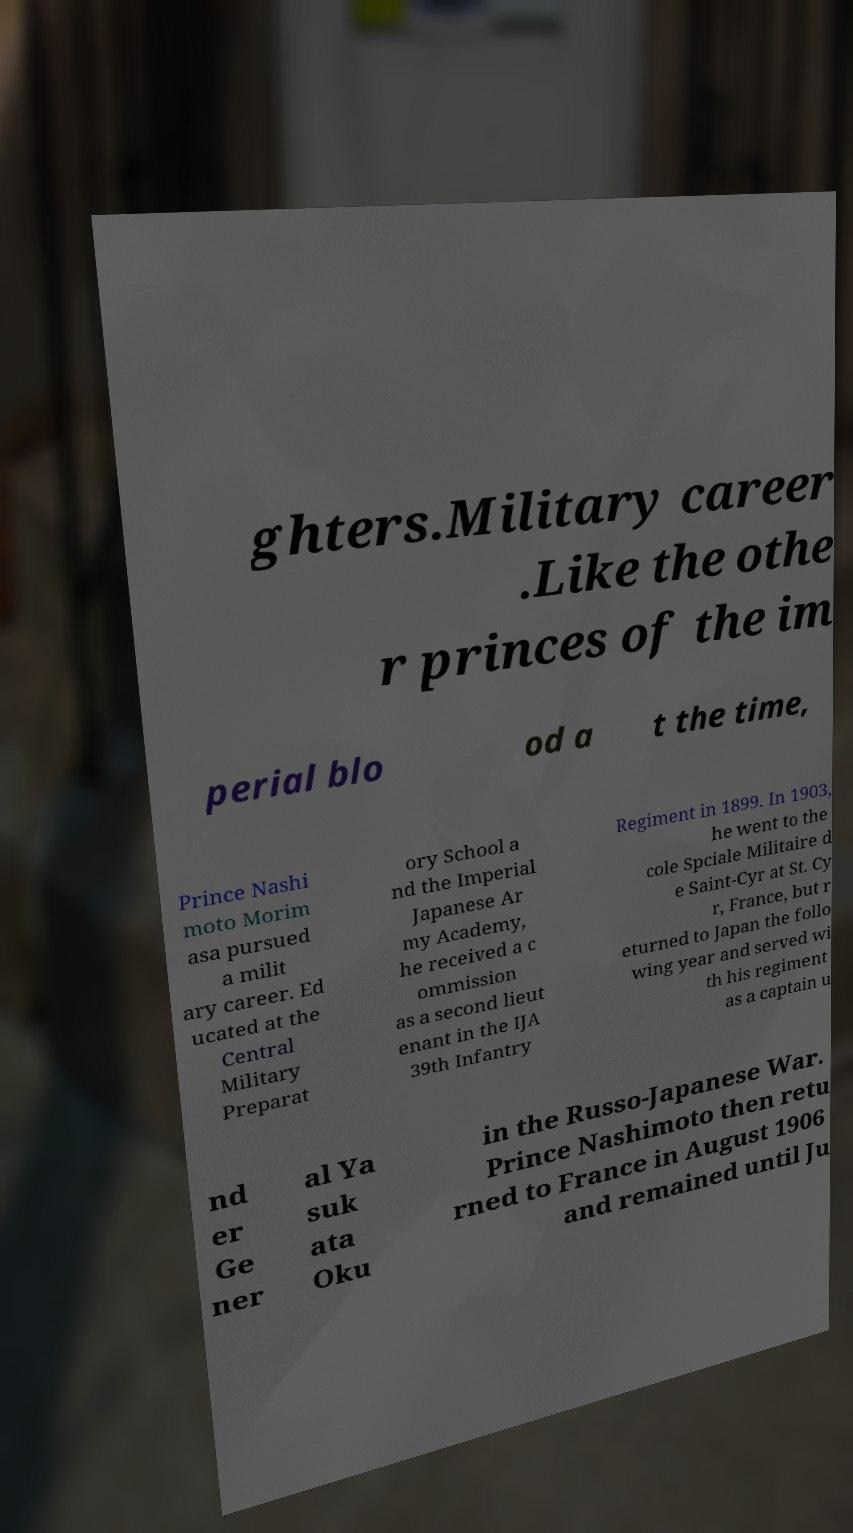Can you accurately transcribe the text from the provided image for me? ghters.Military career .Like the othe r princes of the im perial blo od a t the time, Prince Nashi moto Morim asa pursued a milit ary career. Ed ucated at the Central Military Preparat ory School a nd the Imperial Japanese Ar my Academy, he received a c ommission as a second lieut enant in the IJA 39th Infantry Regiment in 1899. In 1903, he went to the cole Spciale Militaire d e Saint-Cyr at St. Cy r, France, but r eturned to Japan the follo wing year and served wi th his regiment as a captain u nd er Ge ner al Ya suk ata Oku in the Russo-Japanese War. Prince Nashimoto then retu rned to France in August 1906 and remained until Ju 